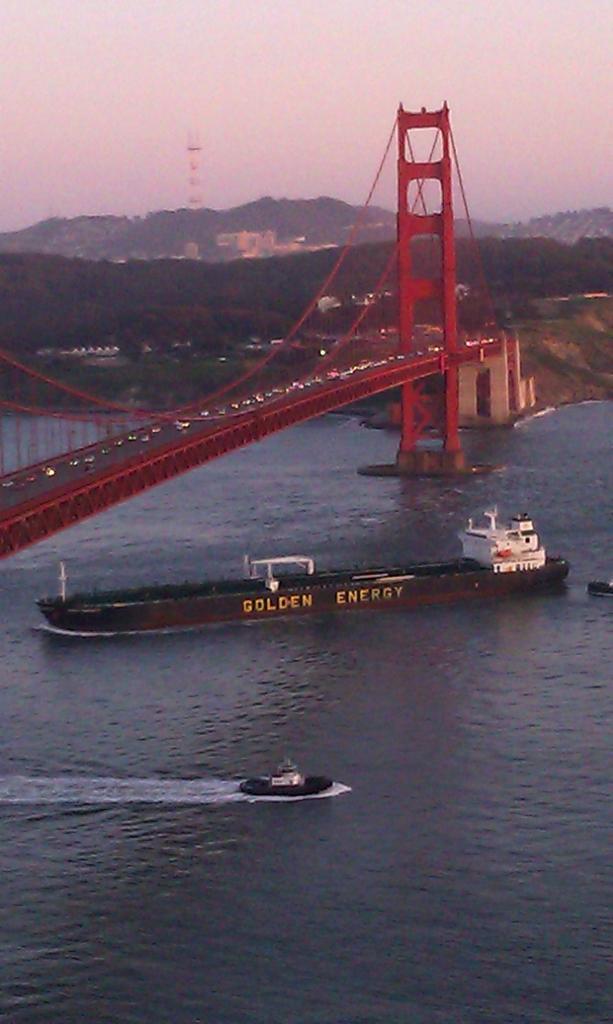Please provide a concise description of this image. There is a ship which is in brown color is on the water and there is a boat beside it and there is a red color bridge above it and there are trees in the background. 